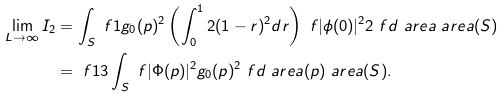<formula> <loc_0><loc_0><loc_500><loc_500>\lim _ { L \to \infty } I _ { 2 } & = \int _ { S } \ f { 1 } { g _ { 0 } ( p ) ^ { 2 } } \left ( \int _ { 0 } ^ { 1 } 2 ( 1 - r ) ^ { 2 } d r \right ) \ f { | \phi ( 0 ) | ^ { 2 } } { 2 } \ f { d \ a r e a } { \ a r e a ( S ) } \\ & = \ f { 1 } { 3 } \int _ { S } \ f { | \Phi ( p ) | ^ { 2 } } { g _ { 0 } ( p ) ^ { 2 } } \ f { d \ a r e a ( p ) } { \ a r e a ( S ) } .</formula> 